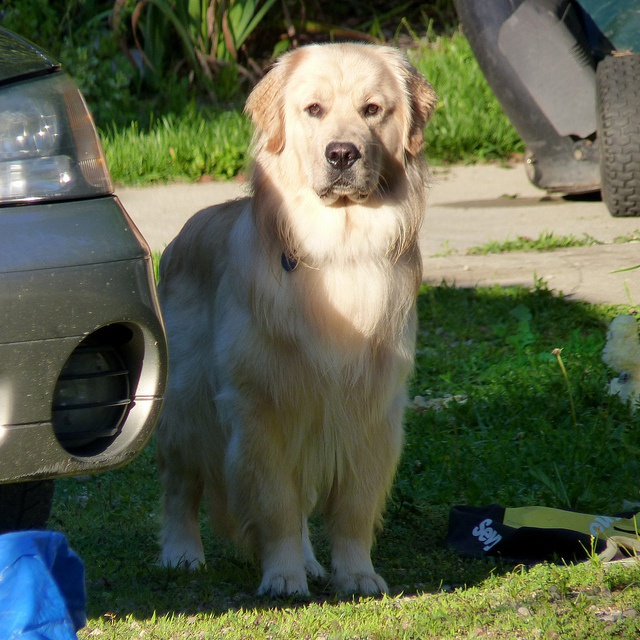Describe the objects in this image and their specific colors. I can see dog in black, gray, darkgreen, and beige tones and car in black, gray, and darkgreen tones in this image. 